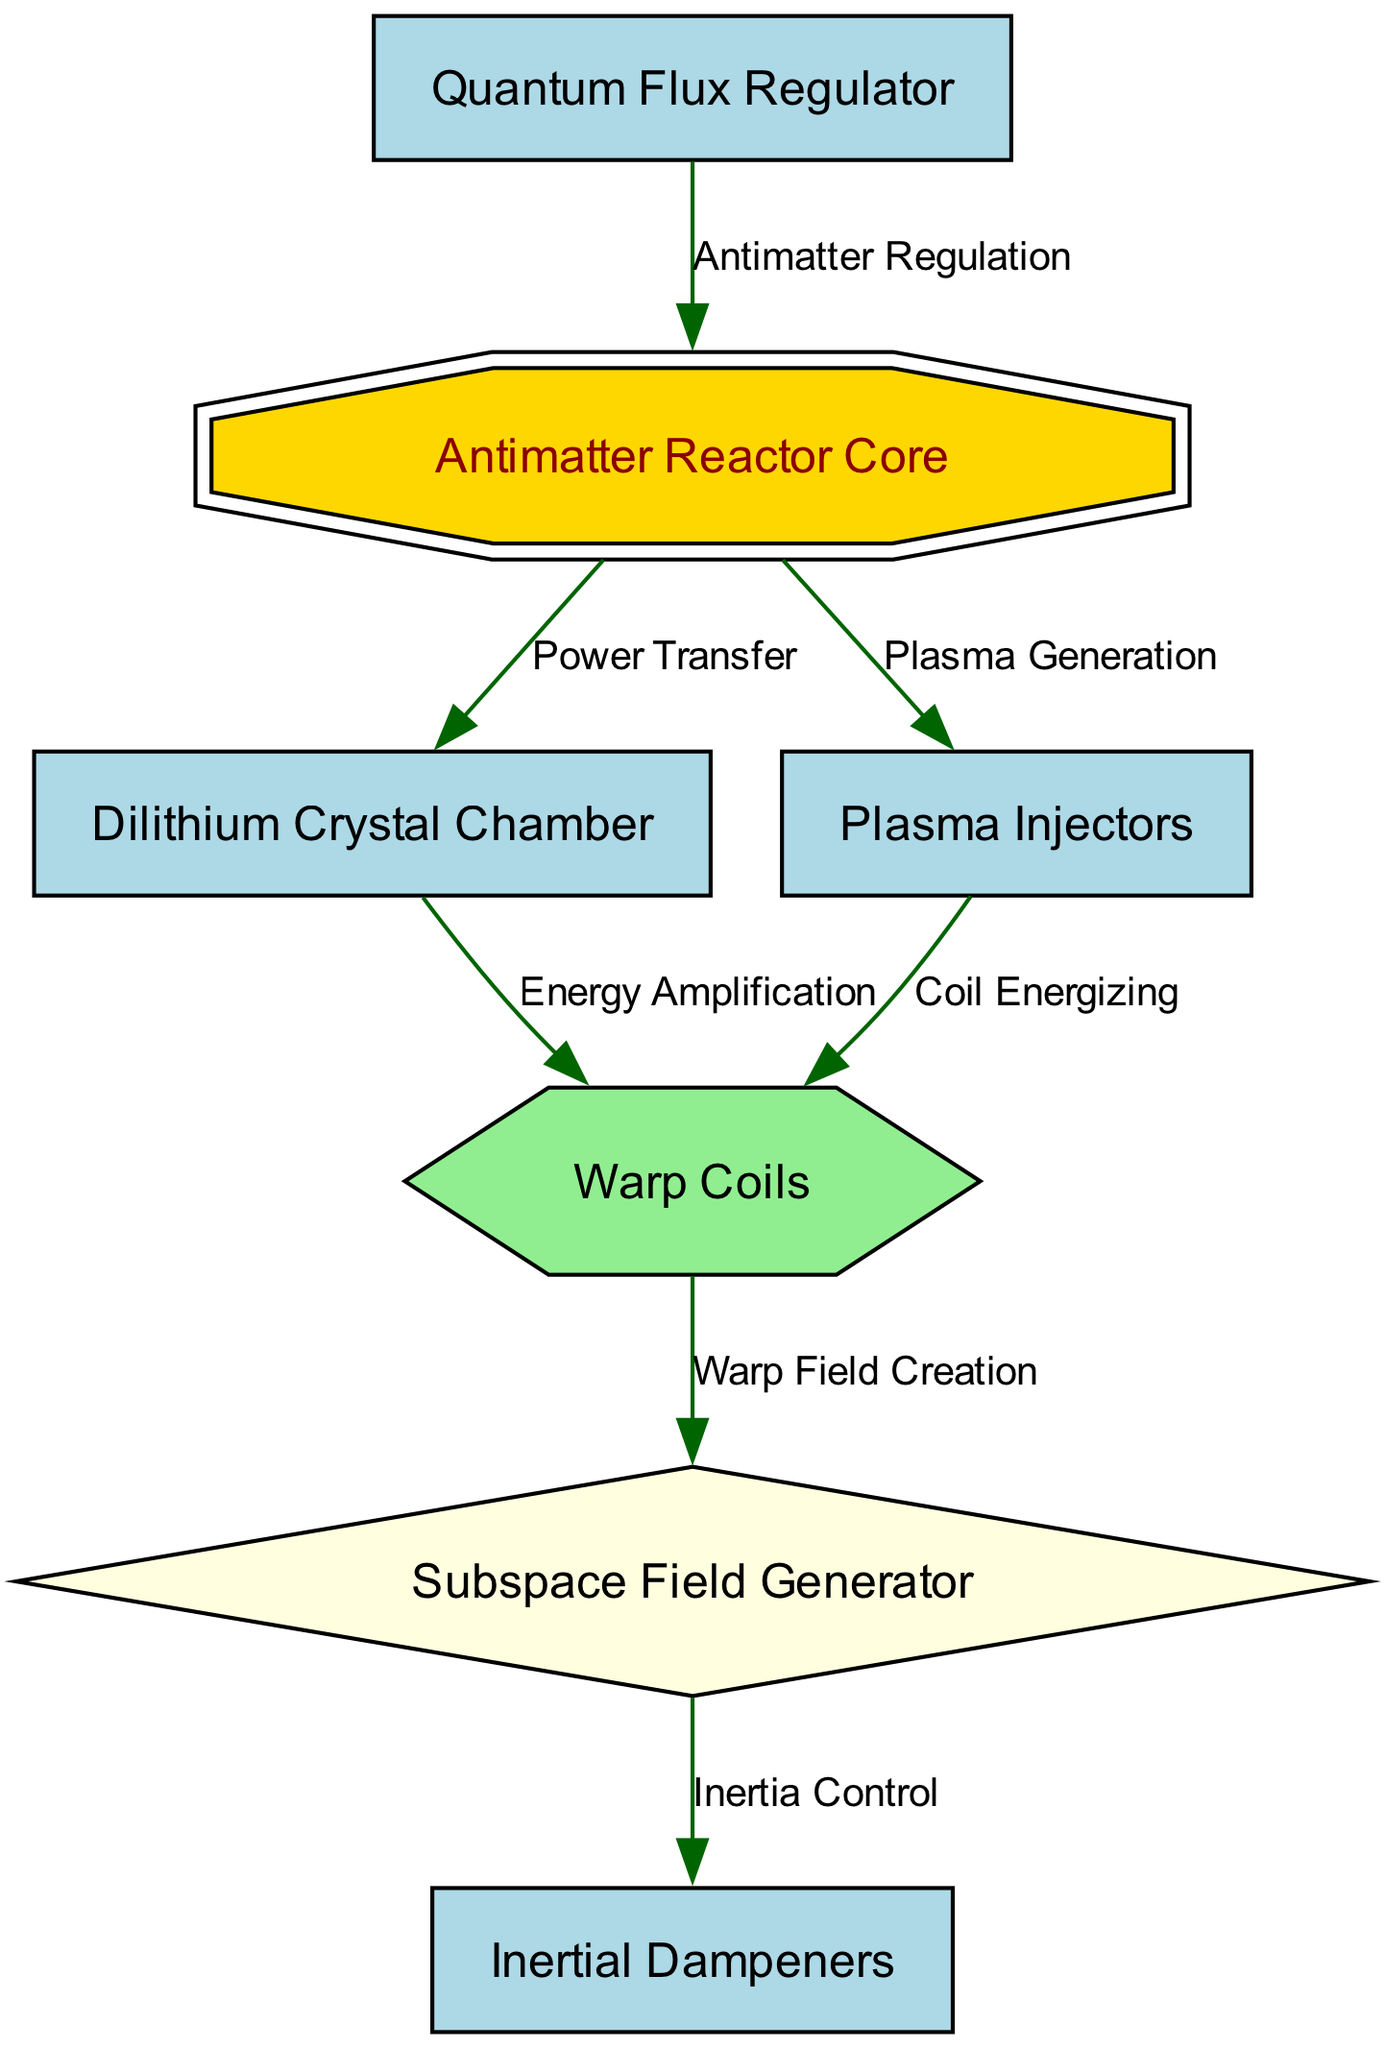What is the primary function of the antimatter reactor core? The antimatter reactor core is primarily responsible for power generation, as it is connected to the dilithium crystal chamber for power transfer.
Answer: Power generation How many energy-generating components are there in the schematic? The schematic contains three primary energy-generating components: the antimatter reactor core, dilithium crystal chamber, and plasma injectors.
Answer: Three What is the relationship between the plasma injectors and warp coils? The plasma injectors energize the warp coils, allowing for the generation of warp fields necessary for faster-than-light travel.
Answer: Coil energizing Which component regulates antimatter? The component that regulates antimatter is the quantum flux regulator; it connects back to the antimatter reactor core to control its operation.
Answer: Quantum flux regulator What links the warp coils to the subspace field generator? The warp coils are connected to the subspace field generator through the warp field creation process, facilitating the manipulation of subspace for interstellar travel.
Answer: Warp field creation What functions do the inertial dampeners serve in the schematic? The inertial dampeners are connected to the subspace field generator to manage inertia effects during propulsion, ensuring smooth travel.
Answer: Inertia control How many nodes are there in total in the diagram? The total number of nodes in the diagram is seven, which represent different components of the spaceship's engine.
Answer: Seven What is the role of the dilithium crystal chamber? The dilithium crystal chamber amplifies energy from the antimatter reactor core before supplying it to the warp coils, enhancing propulsion efficiency.
Answer: Energy amplification Which component is responsible for plasma generation? The plasma generation is handled by the antimatter reactor core, which provides raw power before it is transferred to the plasma injectors.
Answer: Antimatter reactor core 